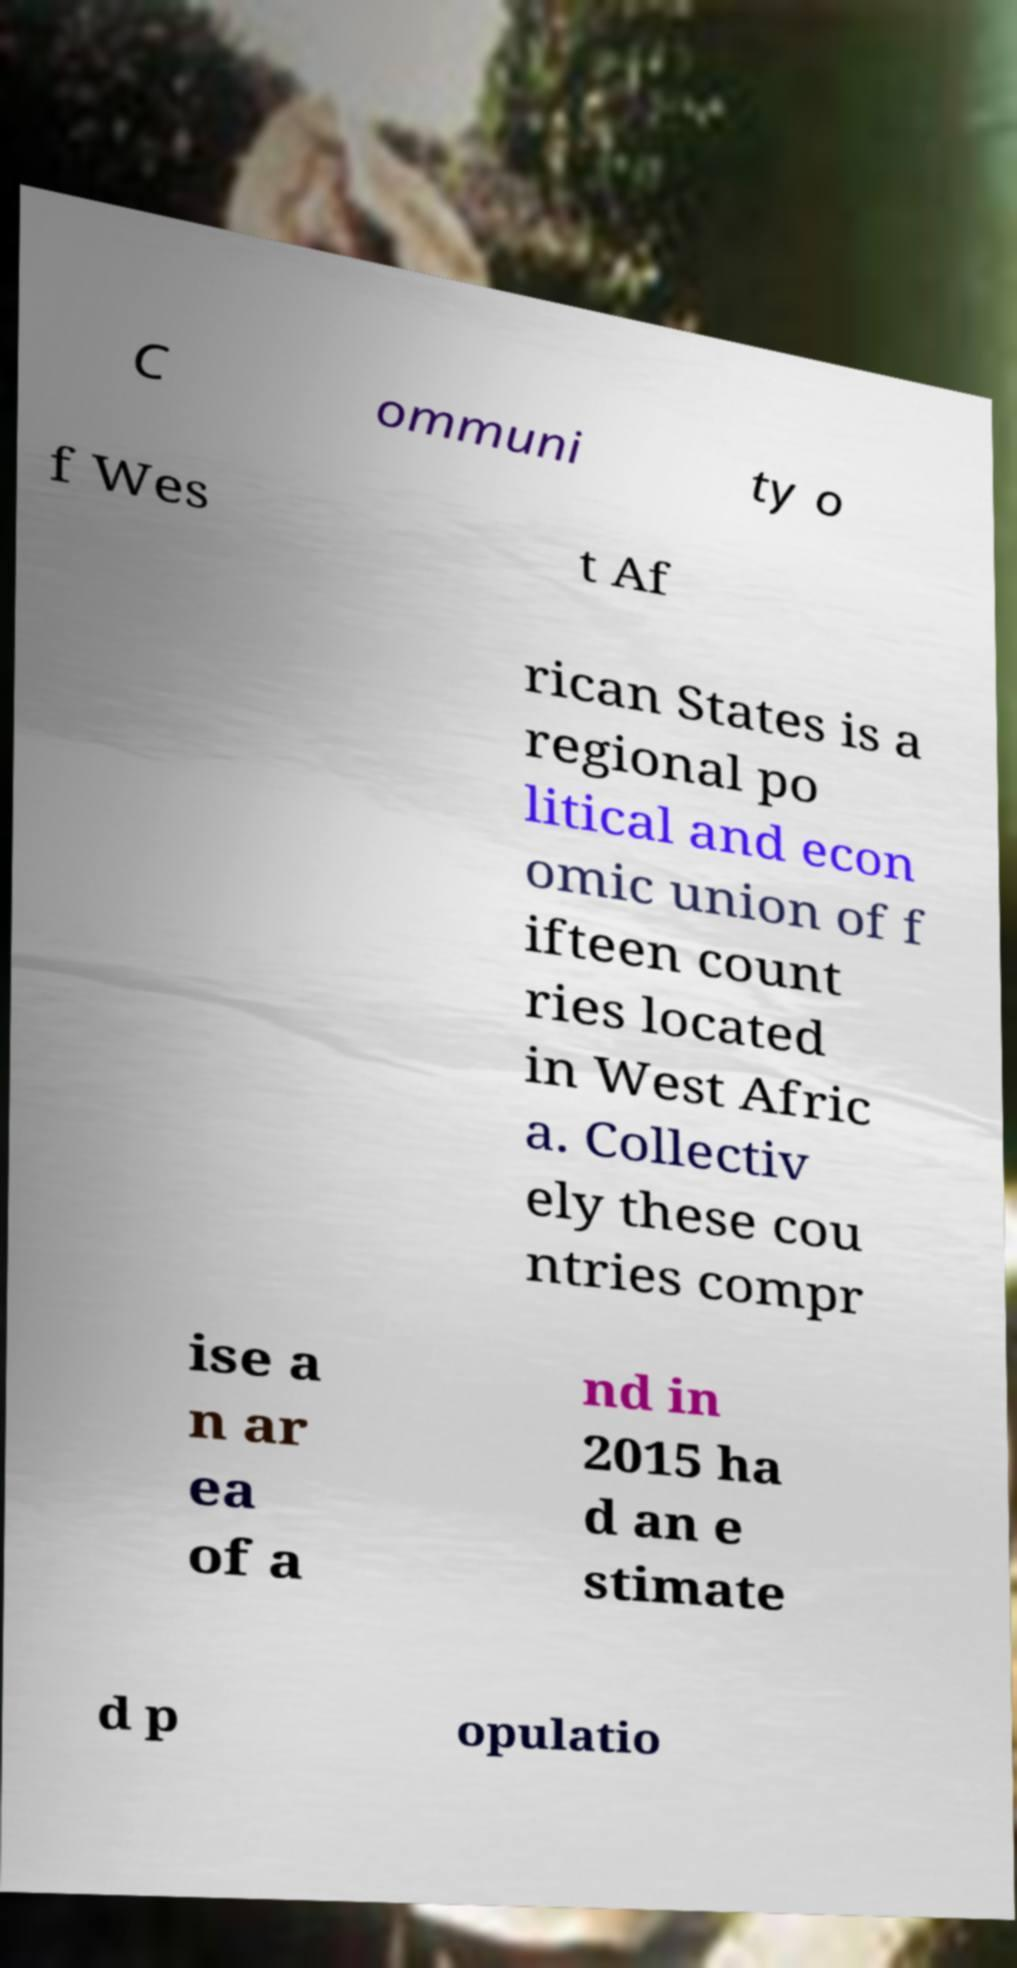Can you read and provide the text displayed in the image?This photo seems to have some interesting text. Can you extract and type it out for me? C ommuni ty o f Wes t Af rican States is a regional po litical and econ omic union of f ifteen count ries located in West Afric a. Collectiv ely these cou ntries compr ise a n ar ea of a nd in 2015 ha d an e stimate d p opulatio 